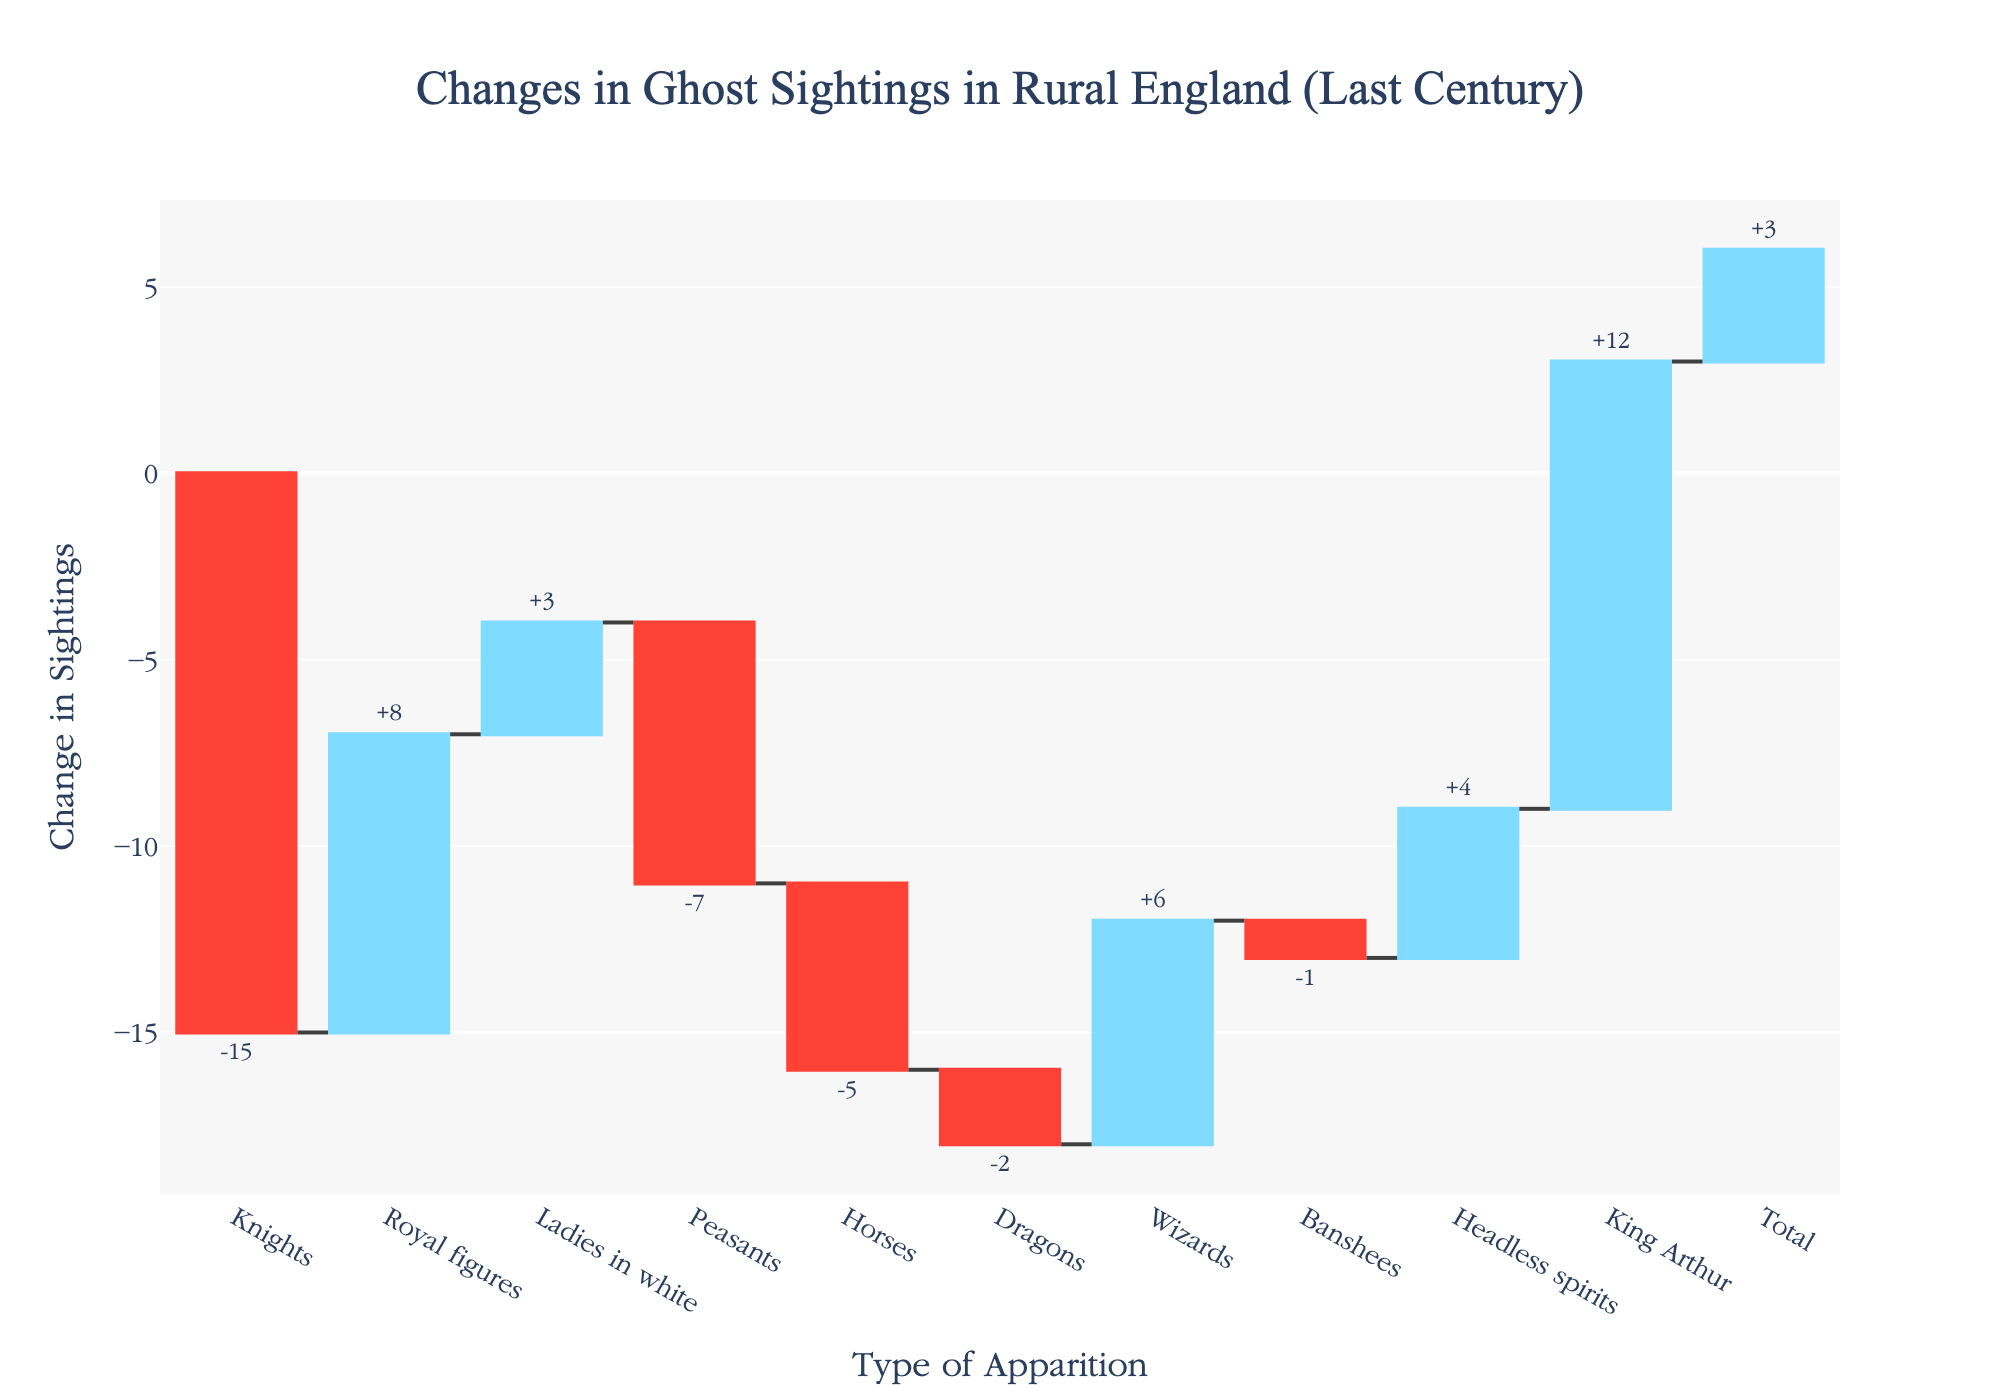How many types of apparitions have seen an increase in sightings? Identify the types with positive changes from the chart: Royal figures, Ladies in white, Wizards, Headless spirits, King Arthur. Count them.
Answer: 5 What's the total change in reported ghost sightings? Look at the "Total" category in the chart which shows the cumulative effect of all other categories. The number provided is +3.
Answer: +3 Out of all the types of apparitions, which one experienced the greatest decrease in sightings? Compare the negative changes. Knights have the largest decrease with -15 sightings.
Answer: Knights How much did the sightings of King Arthur change? Look at the specific data point for King Arthur, which shows +12 sightings.
Answer: +12 Which type of apparition had the smallest change in sightings? The apparition type with the smallest magnitude of change (ignoring sign) is Banshees with -1.
Answer: Banshees What is the net change in sightings for mythological creatures (Dragons and Wizards)? Sum their changes: Dragons (-2) and Wizards (+6). -2 + 6 = +4
Answer: +4 How many apparition categories have seen a decrease in sightings? Identify categories with negative changes from the chart: Knights, Peasants, Horses, Dragons, Banshees. Count them.
Answer: 5 Compare the change in sightings between Royal figures and Ladies in white. Which one increased more? Royal figures increased by +8, while Ladies in white increased by +3. Royal figures had a larger increase.
Answer: Royal figures What is the average change in sightings for the categories with positive changes? Sum the positive changes: (+12) + (+8) + (+6) + (+4) + (+3) = +33. There are 5 categories, so the average is +33 / 5 = +6.6
Answer: +6.6 Which apparition categories have a sighting change equal to or greater than +5? Filter the categories based on changes of >= +5. Look for categories with changes: King Arthur (+12), Royal figures (+8), Wizards (+6).
Answer: King Arthur, Royal figures, Wizards 